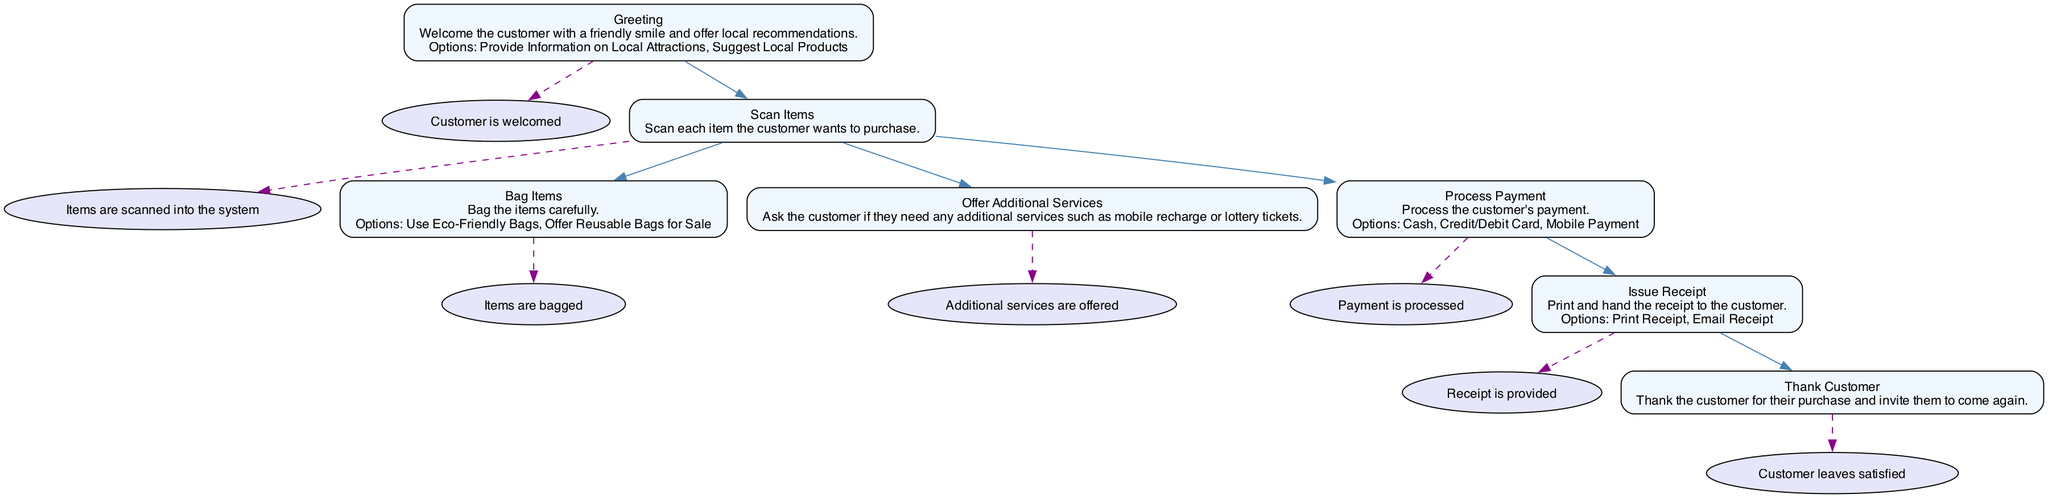What is the first step in the customer checkout procedure? The first step is "Greeting", as indicated in the flowchart. It's the starting node without any dependencies, leading to the customer being welcomed.
Answer: Greeting How many total steps are there in the checkout procedure? By counting the nodes in the diagram, there are 7 distinct steps outlined in the customer checkout procedure.
Answer: 7 Which step follows "Scan Items"? The next step after "Scan Items" is "Bag Items", indicated as a direct follow-up in the flow of the process.
Answer: Bag Items What options are available after "Greeting"? The options provided after the "Greeting" step are "Provide Information on Local Attractions" and "Suggest Local Products" as indicated in the diagram.
Answer: Provide Information on Local Attractions, Suggest Local Products What is the output of the "Process Payment" step? The output for the "Process Payment" step is "Payment is processed", as shown in the diagram's output for that node.
Answer: Payment is processed How many options are available in the "Bag Items" step? The "Bag Items" step has two options: "Use Eco-Friendly Bags" and "Offer Reusable Bags for Sale" visible in the flowchart.
Answer: 2 What is the last step before the customer leaves? The last step before the customer leaves is "Thank Customer," which is followed by the output "Customer leaves satisfied."
Answer: Thank Customer What happens after the "Thank Customer" step? There are no further steps after "Thank Customer," indicating the end of the checkout process.
Answer: End of process What action is taken if a customer opts for a payment method? If a customer opts for a payment method, the action taken is "Process Payment", which is necessary to proceed through the checkout flow.
Answer: Process Payment 